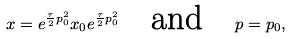Convert formula to latex. <formula><loc_0><loc_0><loc_500><loc_500>x = e ^ { \frac { \tau } { 2 } p _ { 0 } ^ { 2 } } x _ { 0 } e ^ { \frac { \tau } { 2 } p _ { 0 } ^ { 2 } } \quad \text {and\quad } p = p _ { 0 } ,</formula> 